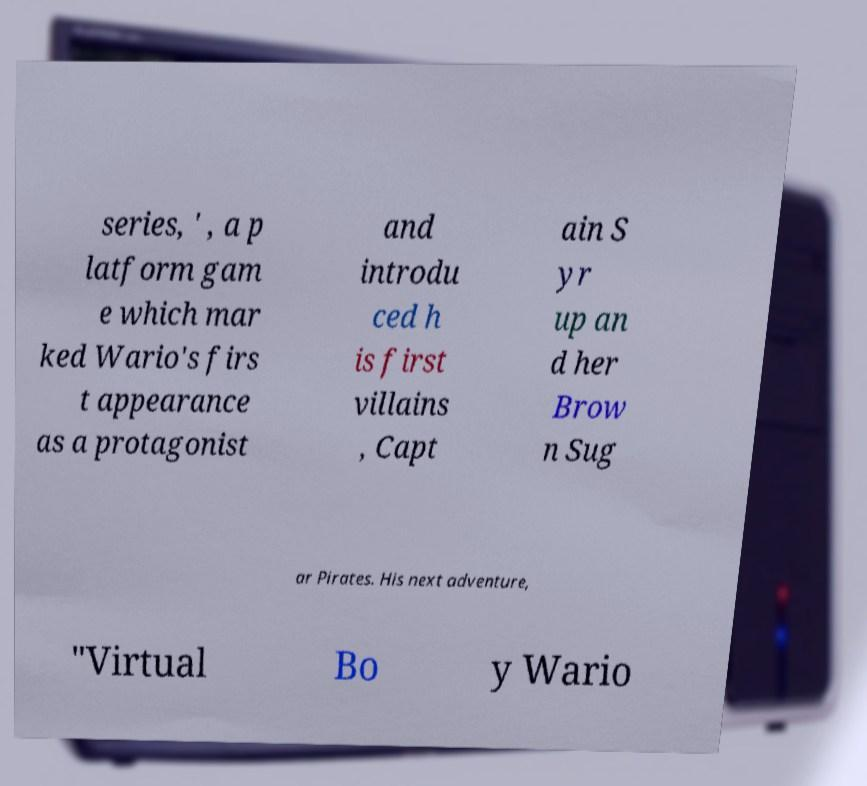Could you assist in decoding the text presented in this image and type it out clearly? series, ' , a p latform gam e which mar ked Wario's firs t appearance as a protagonist and introdu ced h is first villains , Capt ain S yr up an d her Brow n Sug ar Pirates. His next adventure, "Virtual Bo y Wario 